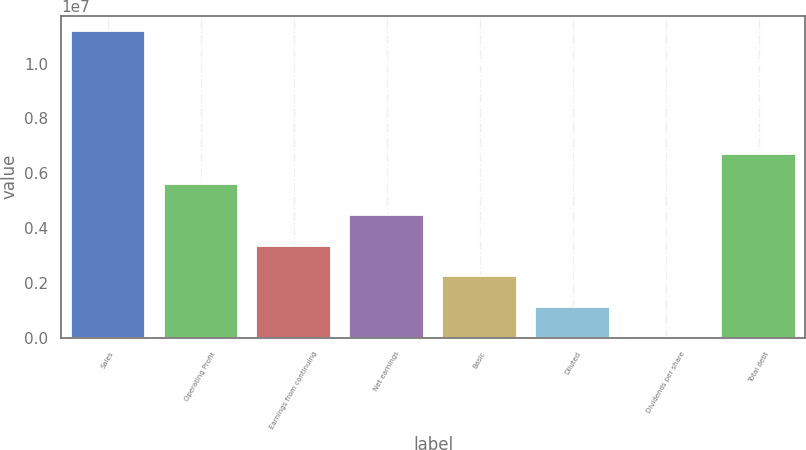Convert chart. <chart><loc_0><loc_0><loc_500><loc_500><bar_chart><fcel>Sales<fcel>Operating Profit<fcel>Earnings from continuing<fcel>Net earnings<fcel>Basic<fcel>Diluted<fcel>Dividends per share<fcel>Total debt<nl><fcel>1.11849e+07<fcel>5.59247e+06<fcel>3.35548e+06<fcel>4.47398e+06<fcel>2.23699e+06<fcel>1.11849e+06<fcel>0.13<fcel>6.71096e+06<nl></chart> 